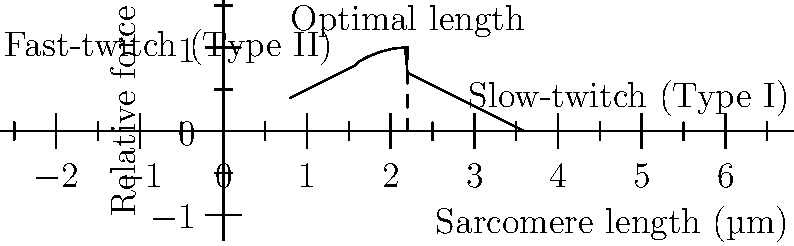Based on the force-length relationship curve shown for different muscle fiber types, at which sarcomere length do both slow-twitch (Type I) and fast-twitch (Type II) muscle fibers generate their maximum force, and how does this relate to the sliding filament theory of muscle contraction? To answer this question, let's analyze the graph and relate it to the sliding filament theory:

1. The graph shows the relative force generated by muscle fibers as a function of sarcomere length.

2. The peak of the curve represents the point of maximum force generation, which occurs at the optimal sarcomere length.

3. From the graph, we can see that the optimal sarcomere length is approximately 2.2 µm for both slow-twitch and fast-twitch fibers, as indicated by the dashed line labeled "Optimal length."

4. The sliding filament theory explains this phenomenon:
   a) Sarcomeres are the basic functional units of muscle fibers.
   b) They contain thick (myosin) and thin (actin) filaments that slide past each other during contraction.
   c) The degree of overlap between these filaments determines the force generated.

5. At the optimal length (2.2 µm):
   a) There is maximal overlap between actin and myosin filaments.
   b) This allows for the maximum number of cross-bridges to form between the filaments.
   c) More cross-bridges result in greater force production.

6. When the sarcomere is shorter or longer than the optimal length:
   a) The overlap between filaments is reduced.
   b) Fewer cross-bridges can form, resulting in less force production.

7. The similarity in optimal length for both fiber types suggests that the basic structure and mechanism of force generation are conserved across different muscle fiber types, despite their functional differences in contraction speed and fatigue resistance.
Answer: 2.2 µm; maximum filament overlap allows for optimal cross-bridge formation. 